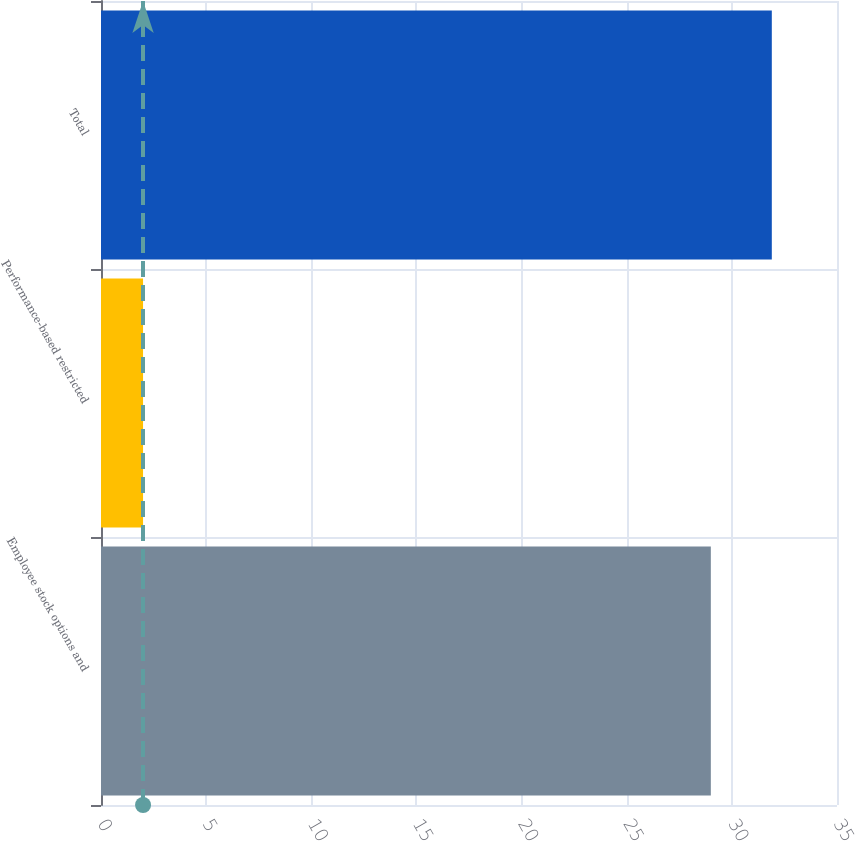Convert chart to OTSL. <chart><loc_0><loc_0><loc_500><loc_500><bar_chart><fcel>Employee stock options and<fcel>Performance-based restricted<fcel>Total<nl><fcel>29<fcel>2<fcel>31.9<nl></chart> 